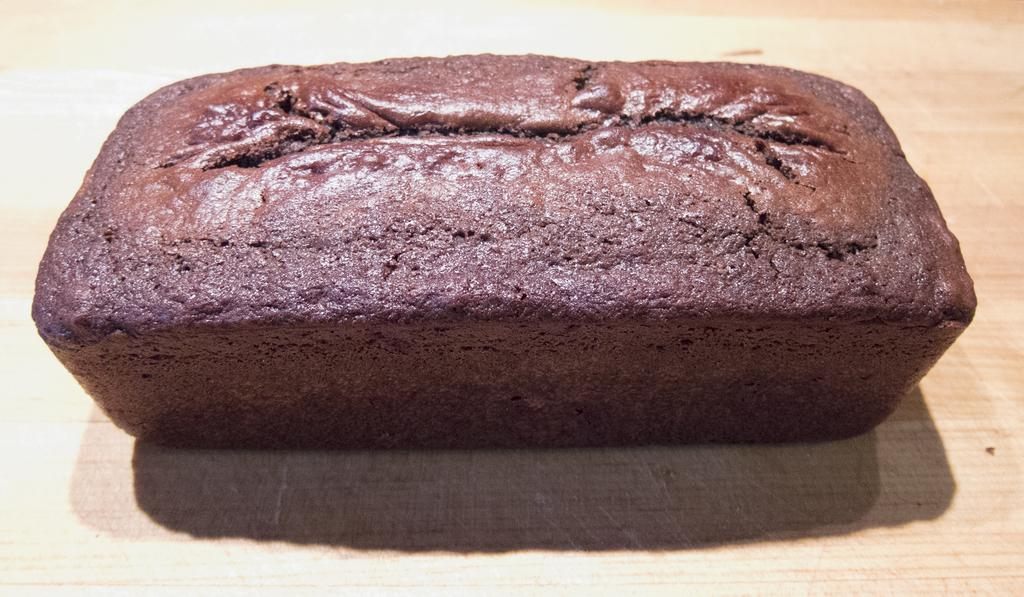What type of cake is in the image? There is a chocolate cake in the image. How is the cake shaped? The cake is rectangular in shape. Where is the cake located in the image? The cake is placed on a table. What color is the cake? The cake is brown in color. What type of whip is being used to advertise the cake's purpose in the image? There is no whip or advertisement present in the image, and the purpose of the cake is not mentioned. 